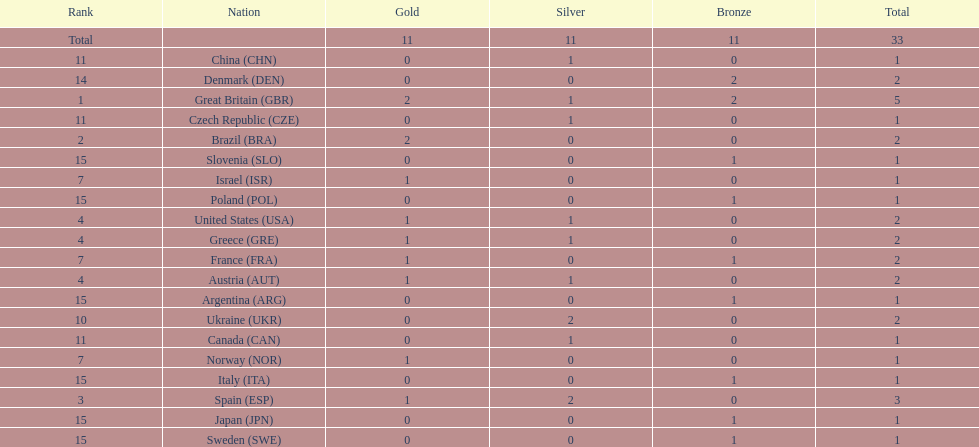Which nation was the only one to receive 3 medals? Spain (ESP). 